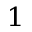<formula> <loc_0><loc_0><loc_500><loc_500>^ { 1 }</formula> 